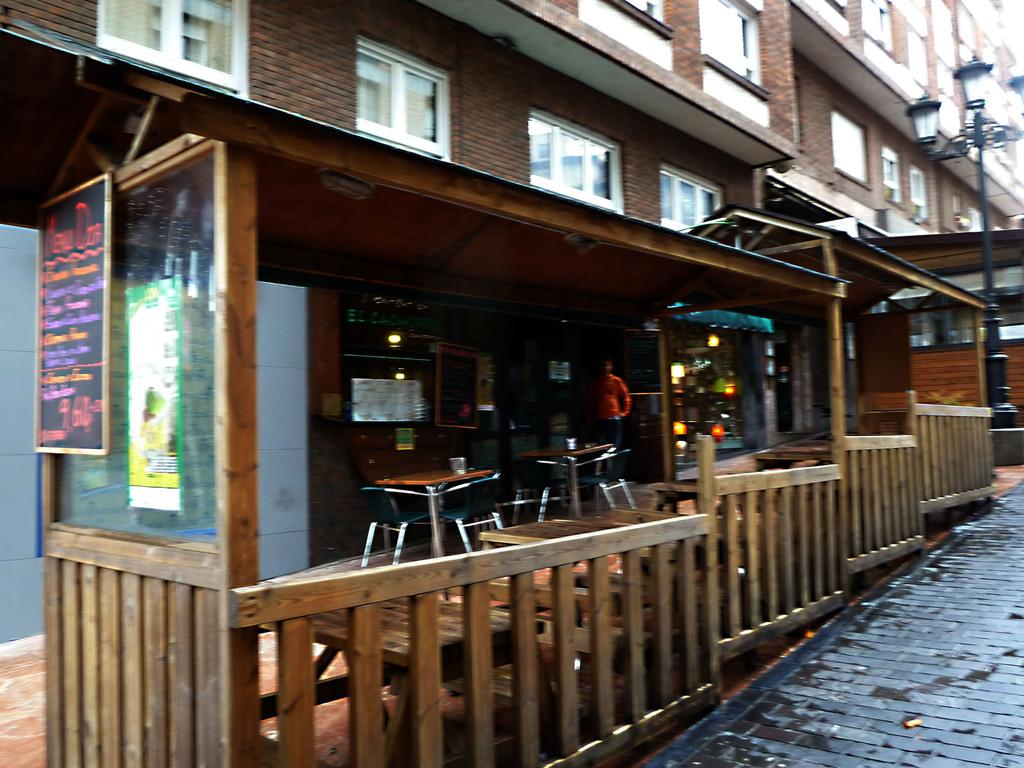What type of structure is visible in the image? There is a building in the image. What feature can be seen on the building? The building has windows. What other objects can be seen in the image? There is a light pole, a wooden fence, a table, and a chair in the image. What can be used to provide illumination in the image? There are lights in the image. Who is present in the image? There is a person in the image. What surface might be used for writing or drawing in the image? There is a glass board in the image. What advice does the person in the image give to the dog? There is no dog present in the image, so no advice can be given. 